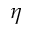<formula> <loc_0><loc_0><loc_500><loc_500>\eta</formula> 